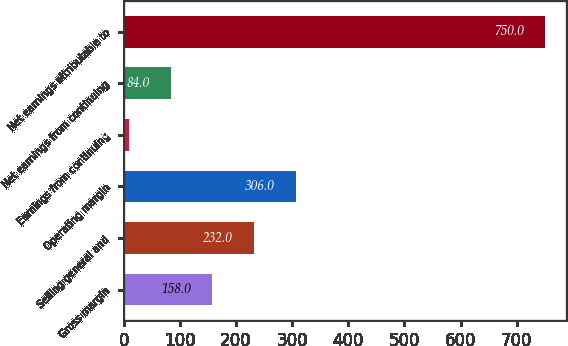<chart> <loc_0><loc_0><loc_500><loc_500><bar_chart><fcel>Gross margin<fcel>Selling general and<fcel>Operating margin<fcel>Earnings from continuing<fcel>Net earnings from continuing<fcel>Net earnings attributable to<nl><fcel>158<fcel>232<fcel>306<fcel>10<fcel>84<fcel>750<nl></chart> 